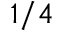Convert formula to latex. <formula><loc_0><loc_0><loc_500><loc_500>1 / 4</formula> 